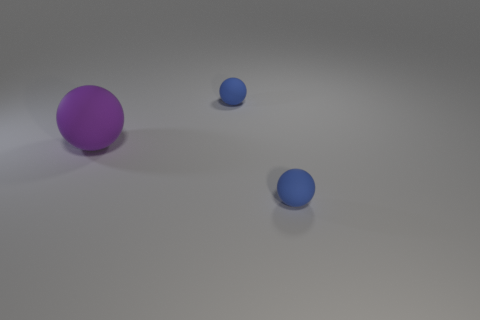There is an object that is left of the small rubber sphere left of the small object that is in front of the large purple thing; how big is it? The object to the left of the small rubber sphere, itself being left of the small object in front of the large purple thing, appears to be medium-sized relative to the other objects in view. 